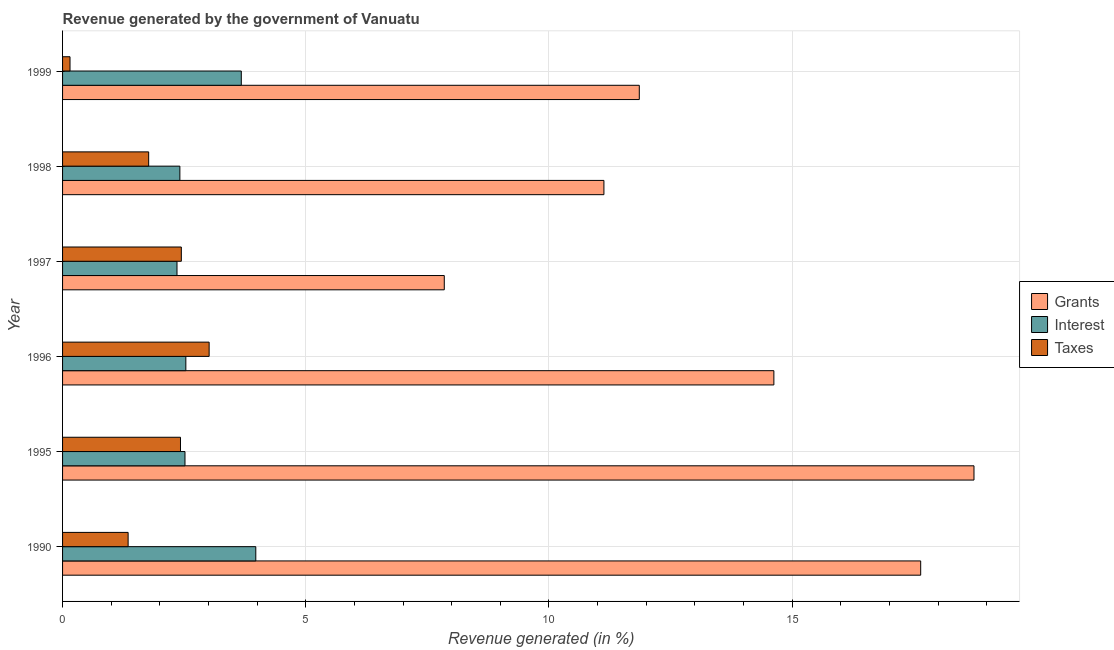How many different coloured bars are there?
Provide a short and direct response. 3. Are the number of bars per tick equal to the number of legend labels?
Offer a terse response. Yes. Are the number of bars on each tick of the Y-axis equal?
Offer a very short reply. Yes. How many bars are there on the 2nd tick from the top?
Provide a short and direct response. 3. How many bars are there on the 1st tick from the bottom?
Keep it short and to the point. 3. What is the percentage of revenue generated by taxes in 1999?
Offer a very short reply. 0.15. Across all years, what is the maximum percentage of revenue generated by grants?
Your response must be concise. 18.74. Across all years, what is the minimum percentage of revenue generated by taxes?
Ensure brevity in your answer.  0.15. In which year was the percentage of revenue generated by grants maximum?
Your response must be concise. 1995. What is the total percentage of revenue generated by grants in the graph?
Make the answer very short. 81.85. What is the difference between the percentage of revenue generated by taxes in 1996 and that in 1998?
Your answer should be compact. 1.24. What is the difference between the percentage of revenue generated by grants in 1996 and the percentage of revenue generated by interest in 1998?
Your answer should be very brief. 12.21. What is the average percentage of revenue generated by taxes per year?
Your answer should be very brief. 1.86. In the year 1999, what is the difference between the percentage of revenue generated by grants and percentage of revenue generated by interest?
Ensure brevity in your answer.  8.18. What is the ratio of the percentage of revenue generated by grants in 1990 to that in 1997?
Your response must be concise. 2.25. Is the difference between the percentage of revenue generated by interest in 1997 and 1998 greater than the difference between the percentage of revenue generated by taxes in 1997 and 1998?
Ensure brevity in your answer.  No. What is the difference between the highest and the second highest percentage of revenue generated by interest?
Provide a succinct answer. 0.3. What is the difference between the highest and the lowest percentage of revenue generated by taxes?
Your response must be concise. 2.86. What does the 1st bar from the top in 1995 represents?
Give a very brief answer. Taxes. What does the 1st bar from the bottom in 1990 represents?
Provide a succinct answer. Grants. How many years are there in the graph?
Your response must be concise. 6. What is the difference between two consecutive major ticks on the X-axis?
Your response must be concise. 5. Are the values on the major ticks of X-axis written in scientific E-notation?
Offer a terse response. No. Does the graph contain any zero values?
Keep it short and to the point. No. Where does the legend appear in the graph?
Your answer should be compact. Center right. How many legend labels are there?
Give a very brief answer. 3. How are the legend labels stacked?
Provide a short and direct response. Vertical. What is the title of the graph?
Give a very brief answer. Revenue generated by the government of Vanuatu. Does "Domestic" appear as one of the legend labels in the graph?
Keep it short and to the point. No. What is the label or title of the X-axis?
Offer a terse response. Revenue generated (in %). What is the label or title of the Y-axis?
Offer a terse response. Year. What is the Revenue generated (in %) in Grants in 1990?
Make the answer very short. 17.64. What is the Revenue generated (in %) in Interest in 1990?
Provide a succinct answer. 3.97. What is the Revenue generated (in %) in Taxes in 1990?
Offer a very short reply. 1.35. What is the Revenue generated (in %) of Grants in 1995?
Keep it short and to the point. 18.74. What is the Revenue generated (in %) in Interest in 1995?
Give a very brief answer. 2.52. What is the Revenue generated (in %) in Taxes in 1995?
Provide a short and direct response. 2.42. What is the Revenue generated (in %) of Grants in 1996?
Your answer should be compact. 14.63. What is the Revenue generated (in %) of Interest in 1996?
Offer a terse response. 2.53. What is the Revenue generated (in %) of Taxes in 1996?
Offer a very short reply. 3.01. What is the Revenue generated (in %) of Grants in 1997?
Offer a terse response. 7.85. What is the Revenue generated (in %) in Interest in 1997?
Your answer should be compact. 2.35. What is the Revenue generated (in %) in Taxes in 1997?
Keep it short and to the point. 2.44. What is the Revenue generated (in %) of Grants in 1998?
Your response must be concise. 11.13. What is the Revenue generated (in %) in Interest in 1998?
Give a very brief answer. 2.41. What is the Revenue generated (in %) in Taxes in 1998?
Your response must be concise. 1.77. What is the Revenue generated (in %) of Grants in 1999?
Your answer should be very brief. 11.86. What is the Revenue generated (in %) of Interest in 1999?
Offer a terse response. 3.68. What is the Revenue generated (in %) in Taxes in 1999?
Provide a succinct answer. 0.15. Across all years, what is the maximum Revenue generated (in %) in Grants?
Keep it short and to the point. 18.74. Across all years, what is the maximum Revenue generated (in %) of Interest?
Make the answer very short. 3.97. Across all years, what is the maximum Revenue generated (in %) of Taxes?
Offer a very short reply. 3.01. Across all years, what is the minimum Revenue generated (in %) of Grants?
Provide a short and direct response. 7.85. Across all years, what is the minimum Revenue generated (in %) in Interest?
Your response must be concise. 2.35. Across all years, what is the minimum Revenue generated (in %) in Taxes?
Offer a terse response. 0.15. What is the total Revenue generated (in %) of Grants in the graph?
Make the answer very short. 81.85. What is the total Revenue generated (in %) of Interest in the graph?
Ensure brevity in your answer.  17.46. What is the total Revenue generated (in %) of Taxes in the graph?
Your answer should be compact. 11.15. What is the difference between the Revenue generated (in %) of Grants in 1990 and that in 1995?
Offer a very short reply. -1.1. What is the difference between the Revenue generated (in %) in Interest in 1990 and that in 1995?
Make the answer very short. 1.46. What is the difference between the Revenue generated (in %) of Taxes in 1990 and that in 1995?
Offer a very short reply. -1.08. What is the difference between the Revenue generated (in %) in Grants in 1990 and that in 1996?
Give a very brief answer. 3.02. What is the difference between the Revenue generated (in %) of Interest in 1990 and that in 1996?
Your answer should be very brief. 1.44. What is the difference between the Revenue generated (in %) of Taxes in 1990 and that in 1996?
Your response must be concise. -1.67. What is the difference between the Revenue generated (in %) of Grants in 1990 and that in 1997?
Provide a succinct answer. 9.8. What is the difference between the Revenue generated (in %) of Interest in 1990 and that in 1997?
Your answer should be compact. 1.62. What is the difference between the Revenue generated (in %) of Taxes in 1990 and that in 1997?
Provide a short and direct response. -1.09. What is the difference between the Revenue generated (in %) of Grants in 1990 and that in 1998?
Your answer should be very brief. 6.51. What is the difference between the Revenue generated (in %) of Interest in 1990 and that in 1998?
Provide a succinct answer. 1.56. What is the difference between the Revenue generated (in %) of Taxes in 1990 and that in 1998?
Keep it short and to the point. -0.42. What is the difference between the Revenue generated (in %) in Grants in 1990 and that in 1999?
Give a very brief answer. 5.79. What is the difference between the Revenue generated (in %) of Interest in 1990 and that in 1999?
Make the answer very short. 0.3. What is the difference between the Revenue generated (in %) of Taxes in 1990 and that in 1999?
Make the answer very short. 1.19. What is the difference between the Revenue generated (in %) in Grants in 1995 and that in 1996?
Ensure brevity in your answer.  4.11. What is the difference between the Revenue generated (in %) of Interest in 1995 and that in 1996?
Your response must be concise. -0.02. What is the difference between the Revenue generated (in %) of Taxes in 1995 and that in 1996?
Your answer should be compact. -0.59. What is the difference between the Revenue generated (in %) in Grants in 1995 and that in 1997?
Your answer should be very brief. 10.89. What is the difference between the Revenue generated (in %) in Interest in 1995 and that in 1997?
Offer a terse response. 0.16. What is the difference between the Revenue generated (in %) in Taxes in 1995 and that in 1997?
Ensure brevity in your answer.  -0.02. What is the difference between the Revenue generated (in %) of Grants in 1995 and that in 1998?
Provide a short and direct response. 7.61. What is the difference between the Revenue generated (in %) in Interest in 1995 and that in 1998?
Your answer should be compact. 0.11. What is the difference between the Revenue generated (in %) in Taxes in 1995 and that in 1998?
Provide a short and direct response. 0.65. What is the difference between the Revenue generated (in %) in Grants in 1995 and that in 1999?
Your response must be concise. 6.88. What is the difference between the Revenue generated (in %) of Interest in 1995 and that in 1999?
Make the answer very short. -1.16. What is the difference between the Revenue generated (in %) in Taxes in 1995 and that in 1999?
Ensure brevity in your answer.  2.27. What is the difference between the Revenue generated (in %) in Grants in 1996 and that in 1997?
Your answer should be compact. 6.78. What is the difference between the Revenue generated (in %) of Interest in 1996 and that in 1997?
Give a very brief answer. 0.18. What is the difference between the Revenue generated (in %) in Taxes in 1996 and that in 1997?
Give a very brief answer. 0.57. What is the difference between the Revenue generated (in %) in Grants in 1996 and that in 1998?
Your answer should be compact. 3.49. What is the difference between the Revenue generated (in %) in Interest in 1996 and that in 1998?
Offer a very short reply. 0.12. What is the difference between the Revenue generated (in %) of Taxes in 1996 and that in 1998?
Offer a very short reply. 1.24. What is the difference between the Revenue generated (in %) of Grants in 1996 and that in 1999?
Your answer should be very brief. 2.77. What is the difference between the Revenue generated (in %) in Interest in 1996 and that in 1999?
Provide a short and direct response. -1.14. What is the difference between the Revenue generated (in %) in Taxes in 1996 and that in 1999?
Your response must be concise. 2.86. What is the difference between the Revenue generated (in %) in Grants in 1997 and that in 1998?
Keep it short and to the point. -3.28. What is the difference between the Revenue generated (in %) of Interest in 1997 and that in 1998?
Make the answer very short. -0.06. What is the difference between the Revenue generated (in %) in Taxes in 1997 and that in 1998?
Your response must be concise. 0.67. What is the difference between the Revenue generated (in %) in Grants in 1997 and that in 1999?
Provide a short and direct response. -4.01. What is the difference between the Revenue generated (in %) of Interest in 1997 and that in 1999?
Your answer should be very brief. -1.32. What is the difference between the Revenue generated (in %) of Taxes in 1997 and that in 1999?
Your response must be concise. 2.29. What is the difference between the Revenue generated (in %) in Grants in 1998 and that in 1999?
Provide a succinct answer. -0.73. What is the difference between the Revenue generated (in %) of Interest in 1998 and that in 1999?
Keep it short and to the point. -1.26. What is the difference between the Revenue generated (in %) of Taxes in 1998 and that in 1999?
Ensure brevity in your answer.  1.62. What is the difference between the Revenue generated (in %) in Grants in 1990 and the Revenue generated (in %) in Interest in 1995?
Provide a short and direct response. 15.13. What is the difference between the Revenue generated (in %) in Grants in 1990 and the Revenue generated (in %) in Taxes in 1995?
Offer a terse response. 15.22. What is the difference between the Revenue generated (in %) of Interest in 1990 and the Revenue generated (in %) of Taxes in 1995?
Offer a terse response. 1.55. What is the difference between the Revenue generated (in %) in Grants in 1990 and the Revenue generated (in %) in Interest in 1996?
Offer a very short reply. 15.11. What is the difference between the Revenue generated (in %) in Grants in 1990 and the Revenue generated (in %) in Taxes in 1996?
Ensure brevity in your answer.  14.63. What is the difference between the Revenue generated (in %) of Interest in 1990 and the Revenue generated (in %) of Taxes in 1996?
Keep it short and to the point. 0.96. What is the difference between the Revenue generated (in %) in Grants in 1990 and the Revenue generated (in %) in Interest in 1997?
Offer a terse response. 15.29. What is the difference between the Revenue generated (in %) of Grants in 1990 and the Revenue generated (in %) of Taxes in 1997?
Your answer should be compact. 15.2. What is the difference between the Revenue generated (in %) of Interest in 1990 and the Revenue generated (in %) of Taxes in 1997?
Give a very brief answer. 1.53. What is the difference between the Revenue generated (in %) of Grants in 1990 and the Revenue generated (in %) of Interest in 1998?
Your response must be concise. 15.23. What is the difference between the Revenue generated (in %) in Grants in 1990 and the Revenue generated (in %) in Taxes in 1998?
Your response must be concise. 15.87. What is the difference between the Revenue generated (in %) in Interest in 1990 and the Revenue generated (in %) in Taxes in 1998?
Provide a short and direct response. 2.2. What is the difference between the Revenue generated (in %) in Grants in 1990 and the Revenue generated (in %) in Interest in 1999?
Your answer should be very brief. 13.97. What is the difference between the Revenue generated (in %) of Grants in 1990 and the Revenue generated (in %) of Taxes in 1999?
Ensure brevity in your answer.  17.49. What is the difference between the Revenue generated (in %) in Interest in 1990 and the Revenue generated (in %) in Taxes in 1999?
Keep it short and to the point. 3.82. What is the difference between the Revenue generated (in %) of Grants in 1995 and the Revenue generated (in %) of Interest in 1996?
Ensure brevity in your answer.  16.21. What is the difference between the Revenue generated (in %) in Grants in 1995 and the Revenue generated (in %) in Taxes in 1996?
Offer a terse response. 15.73. What is the difference between the Revenue generated (in %) in Interest in 1995 and the Revenue generated (in %) in Taxes in 1996?
Keep it short and to the point. -0.5. What is the difference between the Revenue generated (in %) in Grants in 1995 and the Revenue generated (in %) in Interest in 1997?
Keep it short and to the point. 16.39. What is the difference between the Revenue generated (in %) of Grants in 1995 and the Revenue generated (in %) of Taxes in 1997?
Provide a short and direct response. 16.3. What is the difference between the Revenue generated (in %) of Interest in 1995 and the Revenue generated (in %) of Taxes in 1997?
Provide a succinct answer. 0.08. What is the difference between the Revenue generated (in %) of Grants in 1995 and the Revenue generated (in %) of Interest in 1998?
Give a very brief answer. 16.33. What is the difference between the Revenue generated (in %) of Grants in 1995 and the Revenue generated (in %) of Taxes in 1998?
Ensure brevity in your answer.  16.97. What is the difference between the Revenue generated (in %) of Interest in 1995 and the Revenue generated (in %) of Taxes in 1998?
Your answer should be very brief. 0.75. What is the difference between the Revenue generated (in %) of Grants in 1995 and the Revenue generated (in %) of Interest in 1999?
Offer a terse response. 15.06. What is the difference between the Revenue generated (in %) of Grants in 1995 and the Revenue generated (in %) of Taxes in 1999?
Provide a succinct answer. 18.59. What is the difference between the Revenue generated (in %) of Interest in 1995 and the Revenue generated (in %) of Taxes in 1999?
Offer a terse response. 2.36. What is the difference between the Revenue generated (in %) of Grants in 1996 and the Revenue generated (in %) of Interest in 1997?
Keep it short and to the point. 12.27. What is the difference between the Revenue generated (in %) of Grants in 1996 and the Revenue generated (in %) of Taxes in 1997?
Provide a short and direct response. 12.18. What is the difference between the Revenue generated (in %) in Interest in 1996 and the Revenue generated (in %) in Taxes in 1997?
Offer a terse response. 0.09. What is the difference between the Revenue generated (in %) of Grants in 1996 and the Revenue generated (in %) of Interest in 1998?
Offer a terse response. 12.21. What is the difference between the Revenue generated (in %) in Grants in 1996 and the Revenue generated (in %) in Taxes in 1998?
Make the answer very short. 12.85. What is the difference between the Revenue generated (in %) of Interest in 1996 and the Revenue generated (in %) of Taxes in 1998?
Provide a short and direct response. 0.76. What is the difference between the Revenue generated (in %) of Grants in 1996 and the Revenue generated (in %) of Interest in 1999?
Your response must be concise. 10.95. What is the difference between the Revenue generated (in %) in Grants in 1996 and the Revenue generated (in %) in Taxes in 1999?
Your response must be concise. 14.47. What is the difference between the Revenue generated (in %) in Interest in 1996 and the Revenue generated (in %) in Taxes in 1999?
Provide a succinct answer. 2.38. What is the difference between the Revenue generated (in %) in Grants in 1997 and the Revenue generated (in %) in Interest in 1998?
Give a very brief answer. 5.44. What is the difference between the Revenue generated (in %) in Grants in 1997 and the Revenue generated (in %) in Taxes in 1998?
Your response must be concise. 6.08. What is the difference between the Revenue generated (in %) of Interest in 1997 and the Revenue generated (in %) of Taxes in 1998?
Offer a very short reply. 0.58. What is the difference between the Revenue generated (in %) of Grants in 1997 and the Revenue generated (in %) of Interest in 1999?
Your answer should be compact. 4.17. What is the difference between the Revenue generated (in %) of Grants in 1997 and the Revenue generated (in %) of Taxes in 1999?
Offer a very short reply. 7.7. What is the difference between the Revenue generated (in %) of Interest in 1997 and the Revenue generated (in %) of Taxes in 1999?
Your answer should be very brief. 2.2. What is the difference between the Revenue generated (in %) of Grants in 1998 and the Revenue generated (in %) of Interest in 1999?
Offer a terse response. 7.46. What is the difference between the Revenue generated (in %) in Grants in 1998 and the Revenue generated (in %) in Taxes in 1999?
Offer a terse response. 10.98. What is the difference between the Revenue generated (in %) of Interest in 1998 and the Revenue generated (in %) of Taxes in 1999?
Provide a short and direct response. 2.26. What is the average Revenue generated (in %) of Grants per year?
Make the answer very short. 13.64. What is the average Revenue generated (in %) of Interest per year?
Ensure brevity in your answer.  2.91. What is the average Revenue generated (in %) in Taxes per year?
Offer a very short reply. 1.86. In the year 1990, what is the difference between the Revenue generated (in %) in Grants and Revenue generated (in %) in Interest?
Provide a short and direct response. 13.67. In the year 1990, what is the difference between the Revenue generated (in %) in Grants and Revenue generated (in %) in Taxes?
Your answer should be compact. 16.3. In the year 1990, what is the difference between the Revenue generated (in %) of Interest and Revenue generated (in %) of Taxes?
Keep it short and to the point. 2.63. In the year 1995, what is the difference between the Revenue generated (in %) of Grants and Revenue generated (in %) of Interest?
Offer a terse response. 16.22. In the year 1995, what is the difference between the Revenue generated (in %) in Grants and Revenue generated (in %) in Taxes?
Offer a very short reply. 16.32. In the year 1995, what is the difference between the Revenue generated (in %) in Interest and Revenue generated (in %) in Taxes?
Your answer should be very brief. 0.09. In the year 1996, what is the difference between the Revenue generated (in %) of Grants and Revenue generated (in %) of Interest?
Offer a terse response. 12.09. In the year 1996, what is the difference between the Revenue generated (in %) in Grants and Revenue generated (in %) in Taxes?
Your response must be concise. 11.61. In the year 1996, what is the difference between the Revenue generated (in %) of Interest and Revenue generated (in %) of Taxes?
Keep it short and to the point. -0.48. In the year 1997, what is the difference between the Revenue generated (in %) in Grants and Revenue generated (in %) in Interest?
Keep it short and to the point. 5.5. In the year 1997, what is the difference between the Revenue generated (in %) of Grants and Revenue generated (in %) of Taxes?
Your answer should be very brief. 5.41. In the year 1997, what is the difference between the Revenue generated (in %) of Interest and Revenue generated (in %) of Taxes?
Keep it short and to the point. -0.09. In the year 1998, what is the difference between the Revenue generated (in %) in Grants and Revenue generated (in %) in Interest?
Provide a succinct answer. 8.72. In the year 1998, what is the difference between the Revenue generated (in %) of Grants and Revenue generated (in %) of Taxes?
Give a very brief answer. 9.36. In the year 1998, what is the difference between the Revenue generated (in %) of Interest and Revenue generated (in %) of Taxes?
Keep it short and to the point. 0.64. In the year 1999, what is the difference between the Revenue generated (in %) in Grants and Revenue generated (in %) in Interest?
Your answer should be very brief. 8.18. In the year 1999, what is the difference between the Revenue generated (in %) in Grants and Revenue generated (in %) in Taxes?
Provide a succinct answer. 11.71. In the year 1999, what is the difference between the Revenue generated (in %) in Interest and Revenue generated (in %) in Taxes?
Make the answer very short. 3.52. What is the ratio of the Revenue generated (in %) of Grants in 1990 to that in 1995?
Your response must be concise. 0.94. What is the ratio of the Revenue generated (in %) of Interest in 1990 to that in 1995?
Make the answer very short. 1.58. What is the ratio of the Revenue generated (in %) of Taxes in 1990 to that in 1995?
Offer a terse response. 0.56. What is the ratio of the Revenue generated (in %) in Grants in 1990 to that in 1996?
Your response must be concise. 1.21. What is the ratio of the Revenue generated (in %) in Interest in 1990 to that in 1996?
Keep it short and to the point. 1.57. What is the ratio of the Revenue generated (in %) of Taxes in 1990 to that in 1996?
Keep it short and to the point. 0.45. What is the ratio of the Revenue generated (in %) of Grants in 1990 to that in 1997?
Keep it short and to the point. 2.25. What is the ratio of the Revenue generated (in %) of Interest in 1990 to that in 1997?
Your response must be concise. 1.69. What is the ratio of the Revenue generated (in %) in Taxes in 1990 to that in 1997?
Offer a very short reply. 0.55. What is the ratio of the Revenue generated (in %) of Grants in 1990 to that in 1998?
Ensure brevity in your answer.  1.59. What is the ratio of the Revenue generated (in %) of Interest in 1990 to that in 1998?
Keep it short and to the point. 1.65. What is the ratio of the Revenue generated (in %) in Taxes in 1990 to that in 1998?
Your answer should be compact. 0.76. What is the ratio of the Revenue generated (in %) in Grants in 1990 to that in 1999?
Your answer should be very brief. 1.49. What is the ratio of the Revenue generated (in %) in Interest in 1990 to that in 1999?
Offer a very short reply. 1.08. What is the ratio of the Revenue generated (in %) of Taxes in 1990 to that in 1999?
Keep it short and to the point. 8.79. What is the ratio of the Revenue generated (in %) of Grants in 1995 to that in 1996?
Your answer should be compact. 1.28. What is the ratio of the Revenue generated (in %) in Interest in 1995 to that in 1996?
Offer a terse response. 0.99. What is the ratio of the Revenue generated (in %) in Taxes in 1995 to that in 1996?
Ensure brevity in your answer.  0.8. What is the ratio of the Revenue generated (in %) in Grants in 1995 to that in 1997?
Give a very brief answer. 2.39. What is the ratio of the Revenue generated (in %) of Interest in 1995 to that in 1997?
Keep it short and to the point. 1.07. What is the ratio of the Revenue generated (in %) of Taxes in 1995 to that in 1997?
Your answer should be very brief. 0.99. What is the ratio of the Revenue generated (in %) in Grants in 1995 to that in 1998?
Make the answer very short. 1.68. What is the ratio of the Revenue generated (in %) of Interest in 1995 to that in 1998?
Offer a very short reply. 1.04. What is the ratio of the Revenue generated (in %) in Taxes in 1995 to that in 1998?
Your answer should be compact. 1.37. What is the ratio of the Revenue generated (in %) in Grants in 1995 to that in 1999?
Make the answer very short. 1.58. What is the ratio of the Revenue generated (in %) of Interest in 1995 to that in 1999?
Keep it short and to the point. 0.68. What is the ratio of the Revenue generated (in %) of Taxes in 1995 to that in 1999?
Your answer should be compact. 15.82. What is the ratio of the Revenue generated (in %) in Grants in 1996 to that in 1997?
Your response must be concise. 1.86. What is the ratio of the Revenue generated (in %) of Interest in 1996 to that in 1997?
Ensure brevity in your answer.  1.08. What is the ratio of the Revenue generated (in %) in Taxes in 1996 to that in 1997?
Give a very brief answer. 1.23. What is the ratio of the Revenue generated (in %) in Grants in 1996 to that in 1998?
Provide a succinct answer. 1.31. What is the ratio of the Revenue generated (in %) in Interest in 1996 to that in 1998?
Your response must be concise. 1.05. What is the ratio of the Revenue generated (in %) in Taxes in 1996 to that in 1998?
Your answer should be very brief. 1.7. What is the ratio of the Revenue generated (in %) of Grants in 1996 to that in 1999?
Your answer should be very brief. 1.23. What is the ratio of the Revenue generated (in %) of Interest in 1996 to that in 1999?
Provide a short and direct response. 0.69. What is the ratio of the Revenue generated (in %) in Taxes in 1996 to that in 1999?
Give a very brief answer. 19.66. What is the ratio of the Revenue generated (in %) in Grants in 1997 to that in 1998?
Provide a succinct answer. 0.71. What is the ratio of the Revenue generated (in %) of Interest in 1997 to that in 1998?
Keep it short and to the point. 0.98. What is the ratio of the Revenue generated (in %) in Taxes in 1997 to that in 1998?
Keep it short and to the point. 1.38. What is the ratio of the Revenue generated (in %) in Grants in 1997 to that in 1999?
Your answer should be compact. 0.66. What is the ratio of the Revenue generated (in %) in Interest in 1997 to that in 1999?
Your answer should be compact. 0.64. What is the ratio of the Revenue generated (in %) of Taxes in 1997 to that in 1999?
Give a very brief answer. 15.93. What is the ratio of the Revenue generated (in %) in Grants in 1998 to that in 1999?
Give a very brief answer. 0.94. What is the ratio of the Revenue generated (in %) in Interest in 1998 to that in 1999?
Provide a succinct answer. 0.66. What is the ratio of the Revenue generated (in %) of Taxes in 1998 to that in 1999?
Make the answer very short. 11.55. What is the difference between the highest and the second highest Revenue generated (in %) in Grants?
Make the answer very short. 1.1. What is the difference between the highest and the second highest Revenue generated (in %) of Interest?
Give a very brief answer. 0.3. What is the difference between the highest and the second highest Revenue generated (in %) in Taxes?
Ensure brevity in your answer.  0.57. What is the difference between the highest and the lowest Revenue generated (in %) of Grants?
Provide a short and direct response. 10.89. What is the difference between the highest and the lowest Revenue generated (in %) of Interest?
Provide a succinct answer. 1.62. What is the difference between the highest and the lowest Revenue generated (in %) of Taxes?
Your response must be concise. 2.86. 